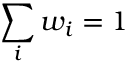Convert formula to latex. <formula><loc_0><loc_0><loc_500><loc_500>\sum _ { i } w _ { i } = 1</formula> 